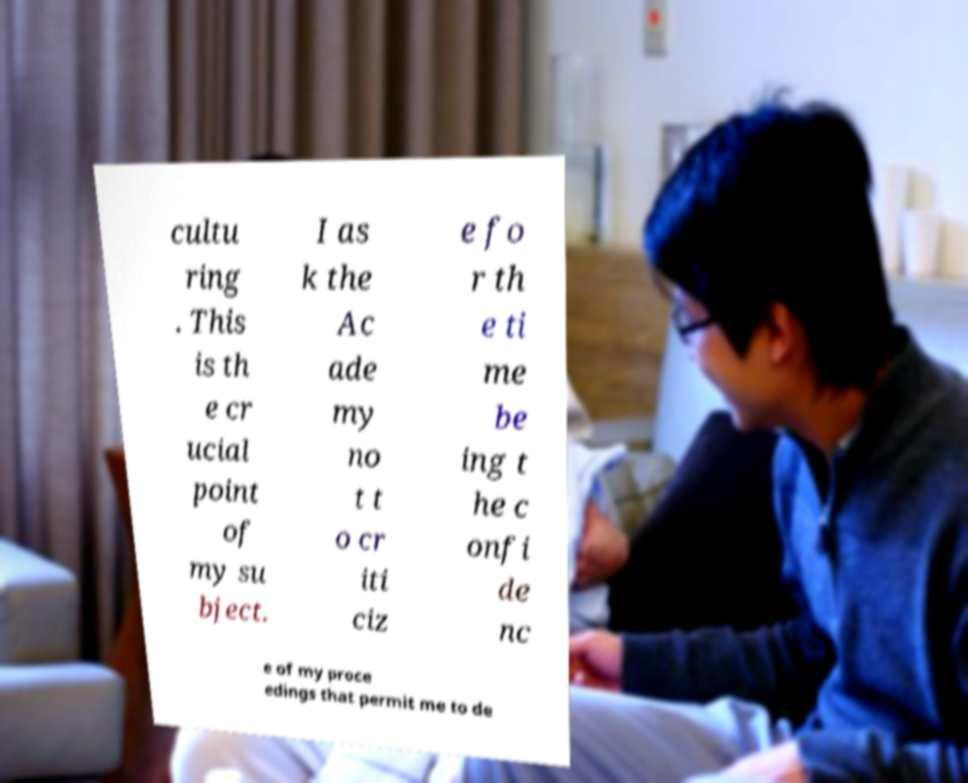There's text embedded in this image that I need extracted. Can you transcribe it verbatim? cultu ring . This is th e cr ucial point of my su bject. I as k the Ac ade my no t t o cr iti ciz e fo r th e ti me be ing t he c onfi de nc e of my proce edings that permit me to de 